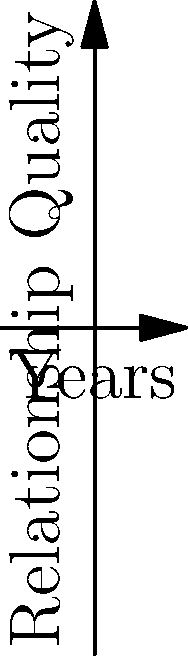Based on the graph showing relationship quality over time for three couples, which couple experiences the most fluctuation in their relationship quality over the 10-year period? To determine which couple experiences the most fluctuation in their relationship quality, we need to analyze the shape and variability of each line:

1. Couple A (blue line): This shows a steady, linear increase over time. There is no fluctuation in the relationship quality.

2. Couple B (red line): This follows a parabolic curve, starting with an increase and then decreasing. While there is some change, it's a smooth transition rather than fluctuation.

3. Couple C (green line): This follows a sinusoidal pattern, showing repeated ups and downs throughout the 10-year period. This represents the most fluctuation among the three couples.

The sinusoidal pattern of Couple C indicates regular periods of higher and lower relationship quality, which is characteristic of more frequent changes or fluctuations in the relationship over time.
Answer: Couple C 